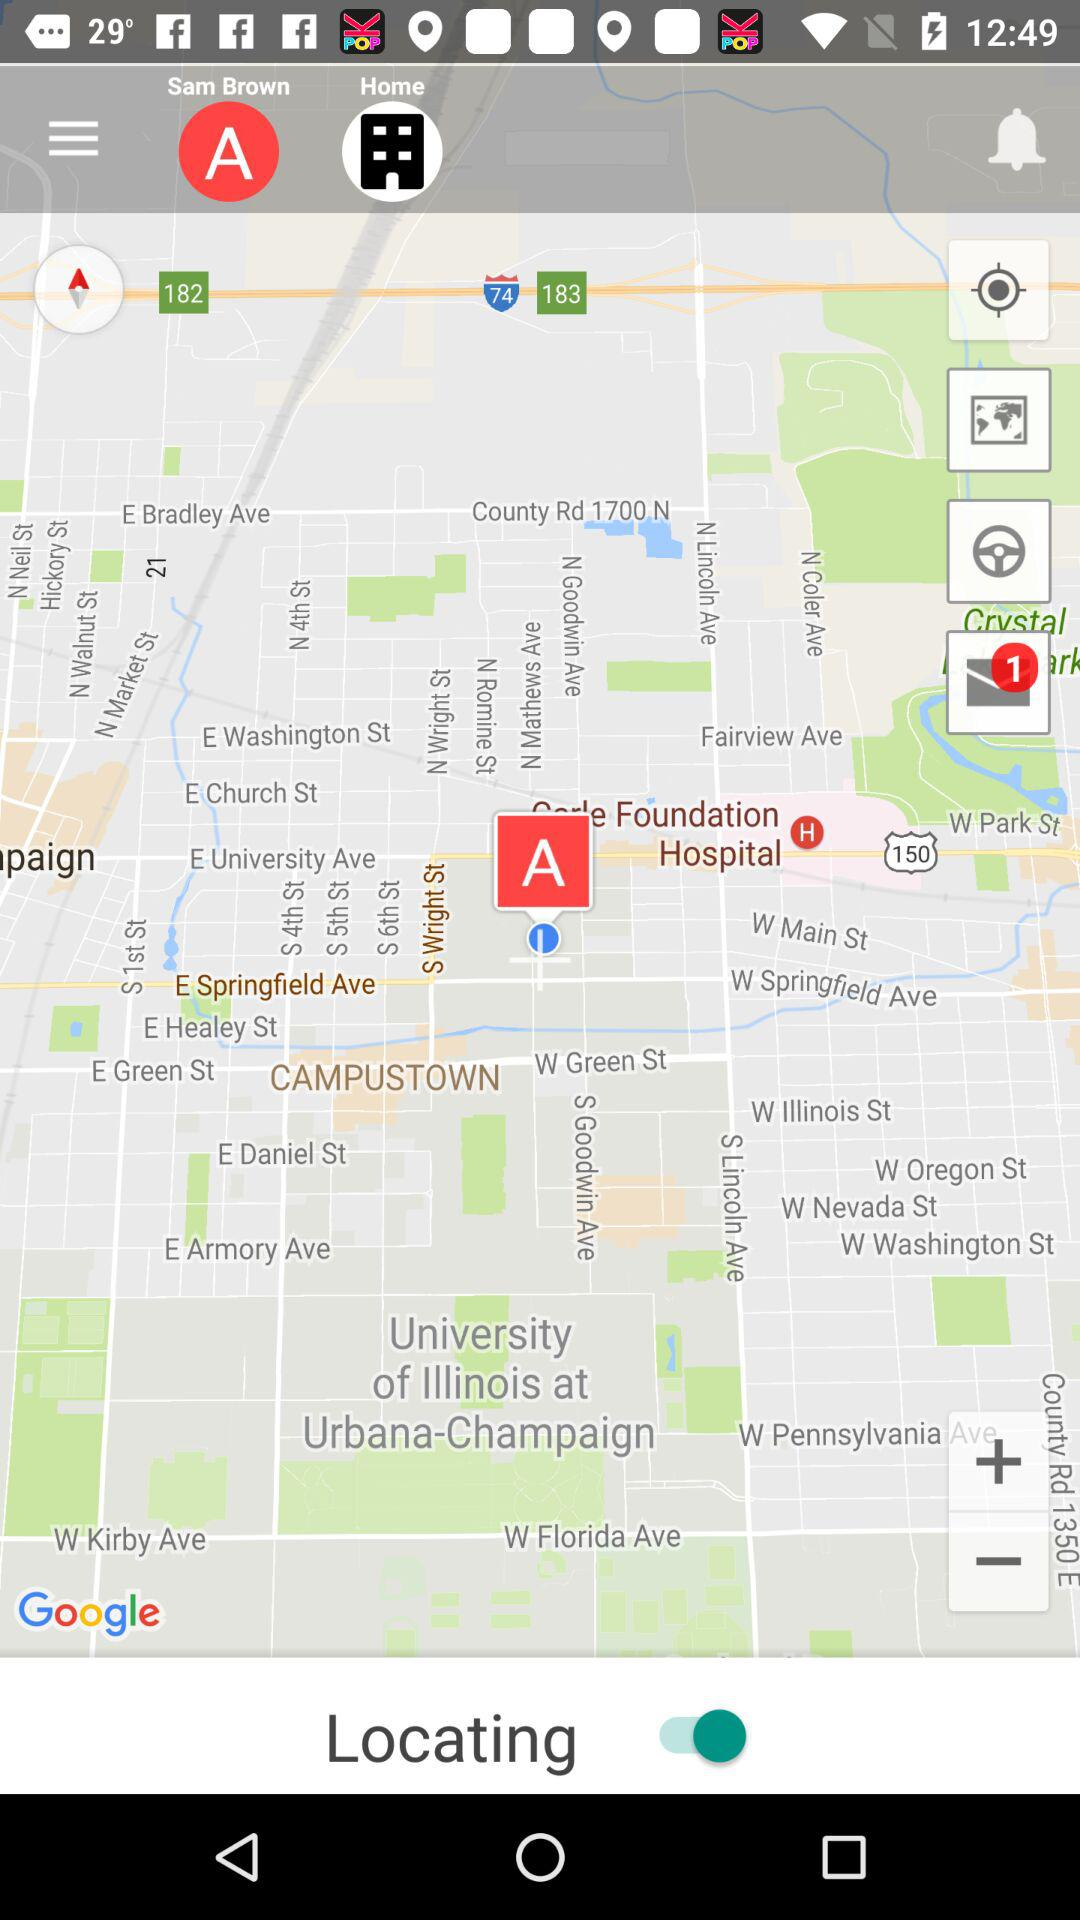What is the count of unread messages? The count of unread messages is one. 